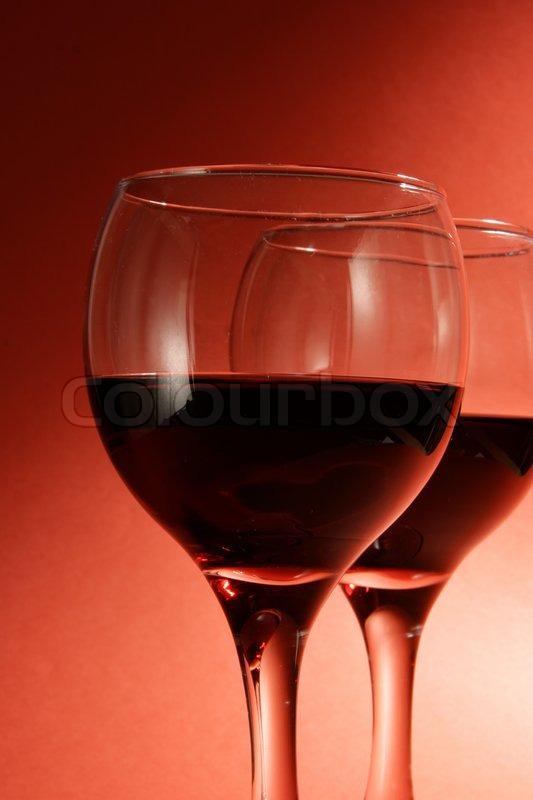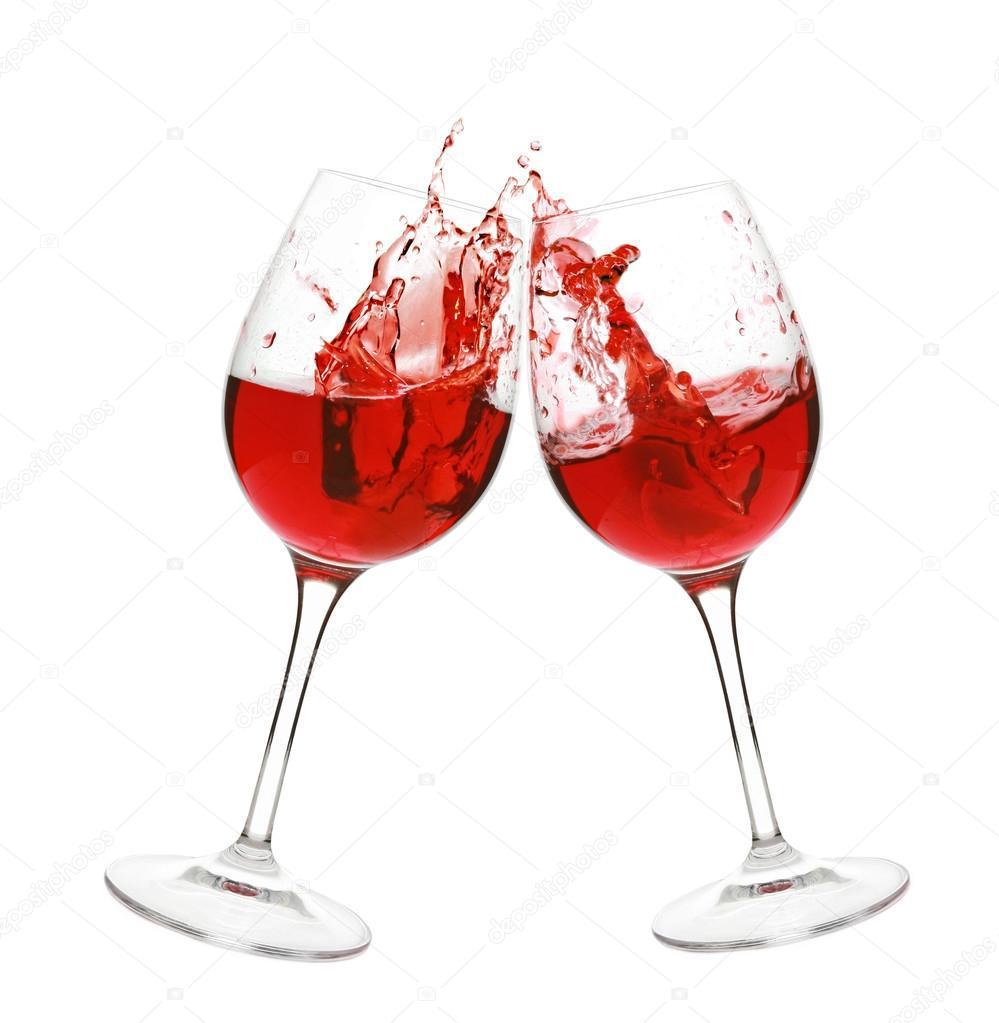The first image is the image on the left, the second image is the image on the right. Evaluate the accuracy of this statement regarding the images: "An image depicts red wine splashing in a stemmed glass.". Is it true? Answer yes or no. Yes. The first image is the image on the left, the second image is the image on the right. For the images displayed, is the sentence "A bottle of wine is near at least one wine glass in one of the images." factually correct? Answer yes or no. No. 